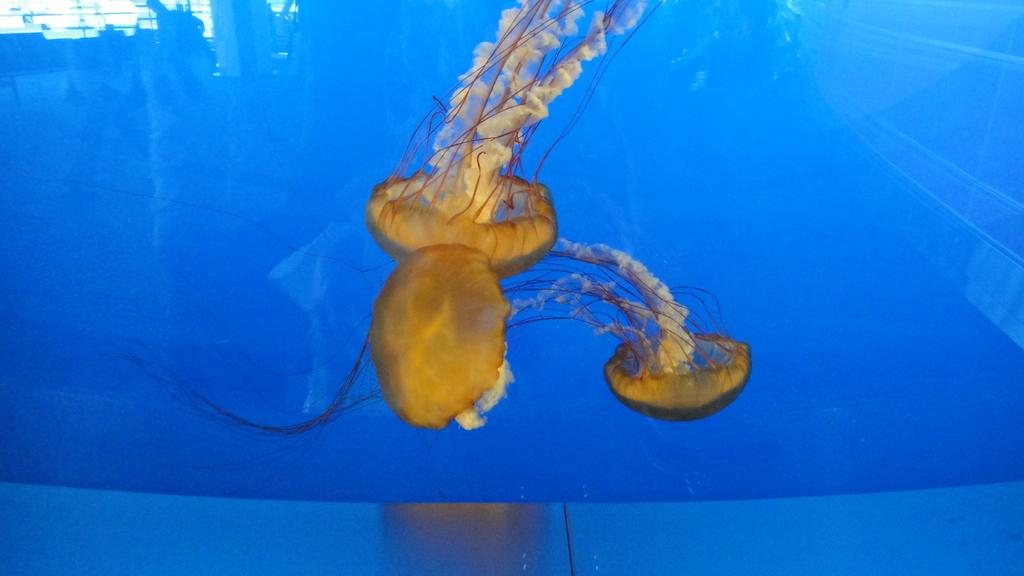What type of animals are in the image? There is a group of jellyfish in the image. Where are the jellyfish located? The jellyfish are in water. What channel is the jellyfish watching in the image? There is no television or channel present in the image; it features a group of jellyfish in water. How does the jellyfish mark its territory in the image? Jellyfish do not mark their territory like some animals do, and there is no indication of territorial behavior in the image. 